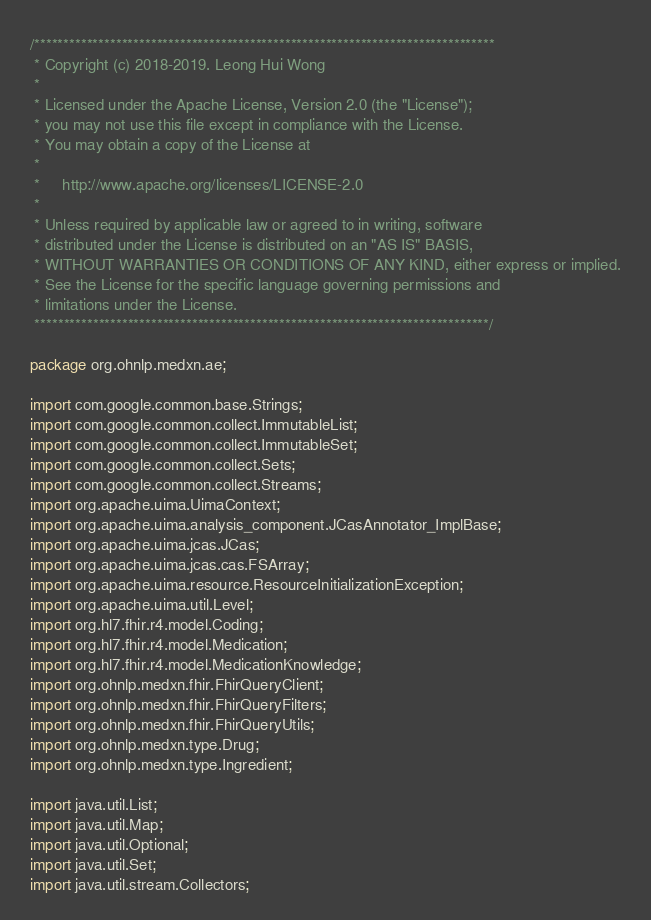<code> <loc_0><loc_0><loc_500><loc_500><_Java_>/*******************************************************************************
 * Copyright (c) 2018-2019. Leong Hui Wong
 *
 * Licensed under the Apache License, Version 2.0 (the "License");
 * you may not use this file except in compliance with the License.
 * You may obtain a copy of the License at
 *
 *     http://www.apache.org/licenses/LICENSE-2.0
 *
 * Unless required by applicable law or agreed to in writing, software
 * distributed under the License is distributed on an "AS IS" BASIS,
 * WITHOUT WARRANTIES OR CONDITIONS OF ANY KIND, either express or implied.
 * See the License for the specific language governing permissions and
 * limitations under the License.
 ******************************************************************************/

package org.ohnlp.medxn.ae;

import com.google.common.base.Strings;
import com.google.common.collect.ImmutableList;
import com.google.common.collect.ImmutableSet;
import com.google.common.collect.Sets;
import com.google.common.collect.Streams;
import org.apache.uima.UimaContext;
import org.apache.uima.analysis_component.JCasAnnotator_ImplBase;
import org.apache.uima.jcas.JCas;
import org.apache.uima.jcas.cas.FSArray;
import org.apache.uima.resource.ResourceInitializationException;
import org.apache.uima.util.Level;
import org.hl7.fhir.r4.model.Coding;
import org.hl7.fhir.r4.model.Medication;
import org.hl7.fhir.r4.model.MedicationKnowledge;
import org.ohnlp.medxn.fhir.FhirQueryClient;
import org.ohnlp.medxn.fhir.FhirQueryFilters;
import org.ohnlp.medxn.fhir.FhirQueryUtils;
import org.ohnlp.medxn.type.Drug;
import org.ohnlp.medxn.type.Ingredient;

import java.util.List;
import java.util.Map;
import java.util.Optional;
import java.util.Set;
import java.util.stream.Collectors;</code> 